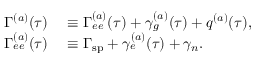<formula> <loc_0><loc_0><loc_500><loc_500>\begin{array} { r l } { \Gamma ^ { ( a ) } ( \tau ) } & \equiv \Gamma _ { e e } ^ { ( a ) } ( \tau ) + \gamma _ { g } ^ { ( a ) } ( \tau ) + q ^ { ( a ) } ( \tau ) , } \\ { \Gamma _ { e e } ^ { ( a ) } ( \tau ) } & \equiv \Gamma _ { s p } + \gamma _ { e } ^ { ( a ) } ( \tau ) + \gamma _ { n } . } \end{array}</formula> 